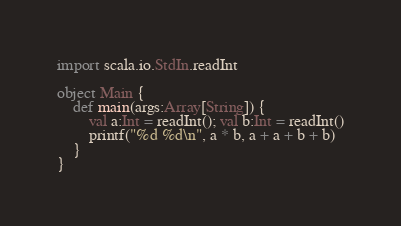<code> <loc_0><loc_0><loc_500><loc_500><_Scala_>import scala.io.StdIn.readInt

object Main {
	def main(args:Array[String]) {
		val a:Int = readInt(); val b:Int = readInt()
		printf("%d %d\n", a * b, a + a + b + b)
	}
}</code> 